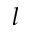Convert formula to latex. <formula><loc_0><loc_0><loc_500><loc_500>l</formula> 